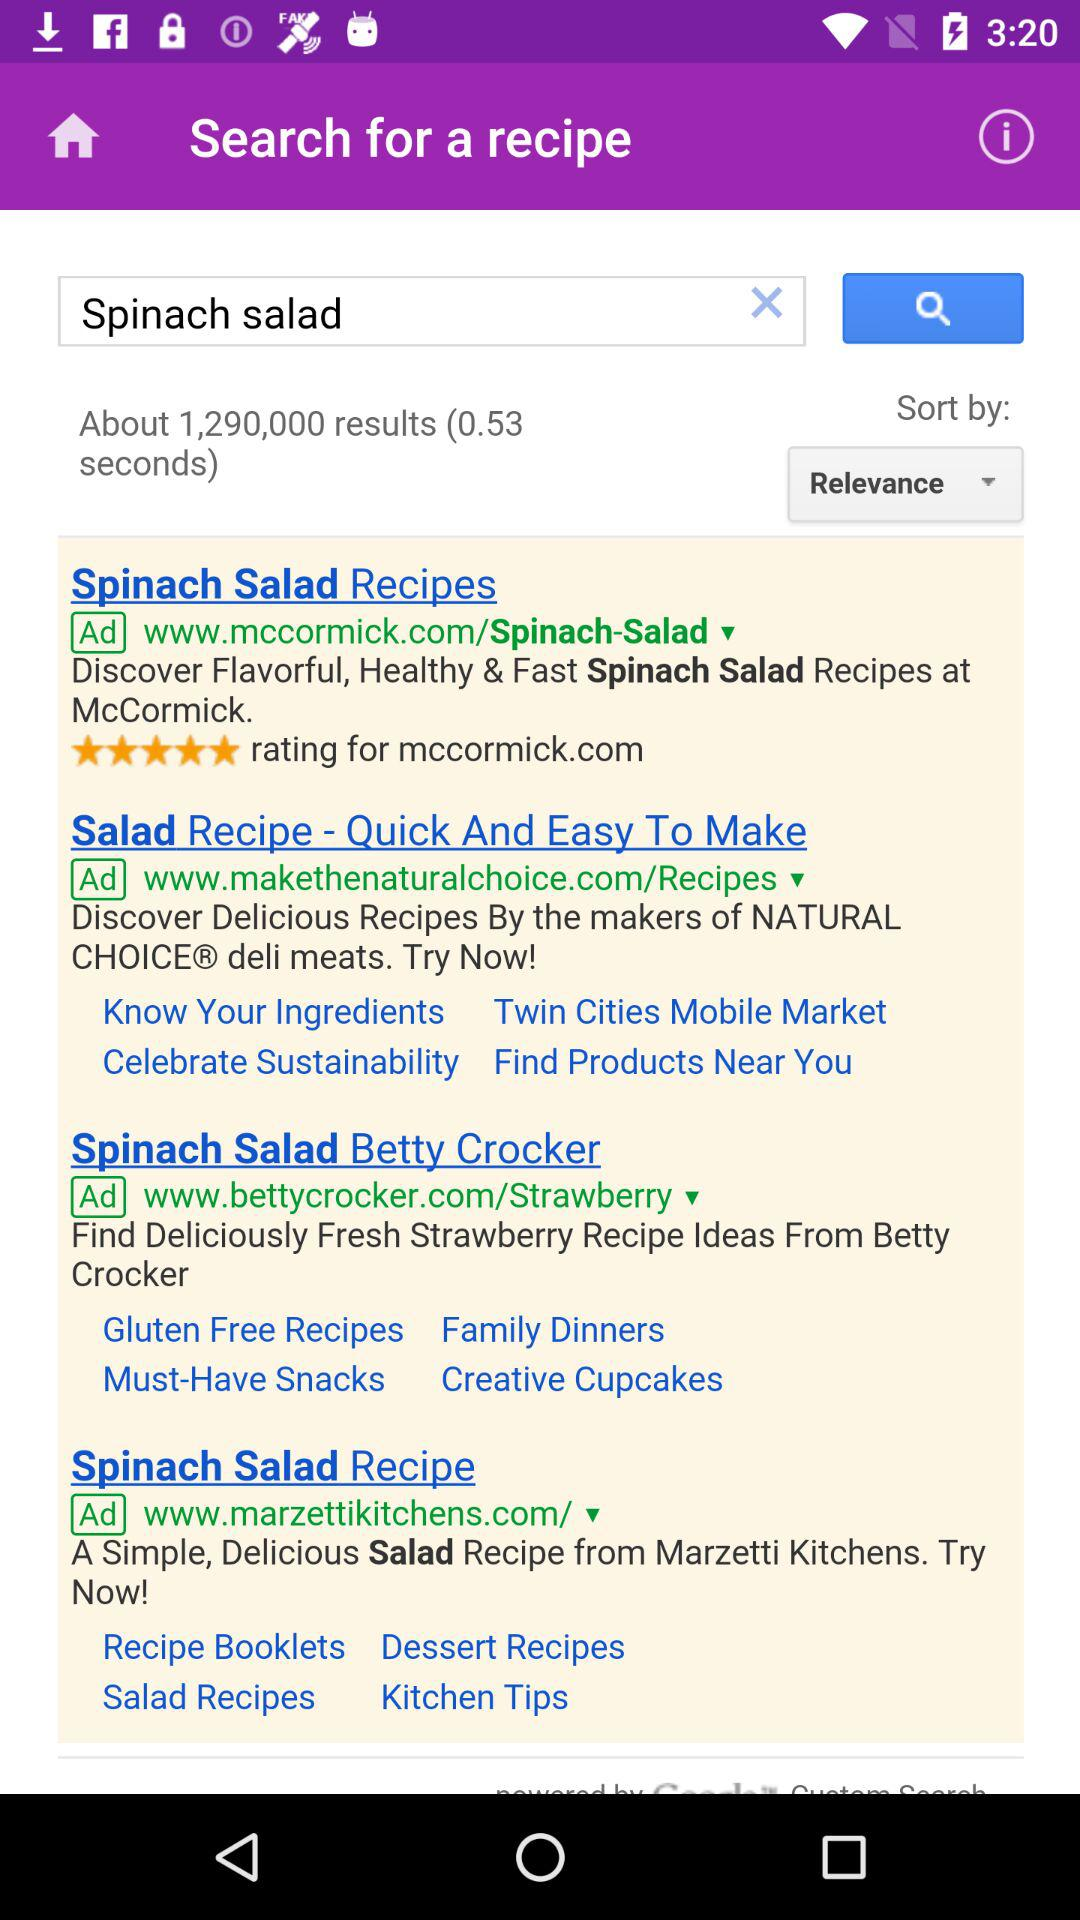What's the total number of results? The total number of results is about 1,290,000. 